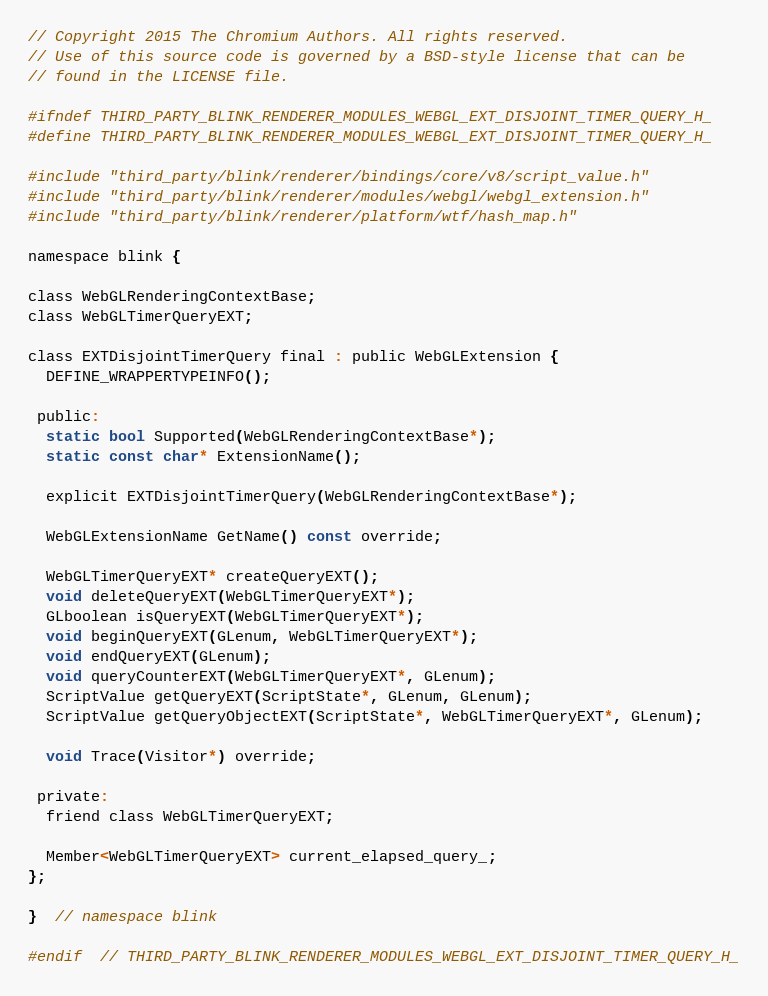<code> <loc_0><loc_0><loc_500><loc_500><_C_>// Copyright 2015 The Chromium Authors. All rights reserved.
// Use of this source code is governed by a BSD-style license that can be
// found in the LICENSE file.

#ifndef THIRD_PARTY_BLINK_RENDERER_MODULES_WEBGL_EXT_DISJOINT_TIMER_QUERY_H_
#define THIRD_PARTY_BLINK_RENDERER_MODULES_WEBGL_EXT_DISJOINT_TIMER_QUERY_H_

#include "third_party/blink/renderer/bindings/core/v8/script_value.h"
#include "third_party/blink/renderer/modules/webgl/webgl_extension.h"
#include "third_party/blink/renderer/platform/wtf/hash_map.h"

namespace blink {

class WebGLRenderingContextBase;
class WebGLTimerQueryEXT;

class EXTDisjointTimerQuery final : public WebGLExtension {
  DEFINE_WRAPPERTYPEINFO();

 public:
  static bool Supported(WebGLRenderingContextBase*);
  static const char* ExtensionName();

  explicit EXTDisjointTimerQuery(WebGLRenderingContextBase*);

  WebGLExtensionName GetName() const override;

  WebGLTimerQueryEXT* createQueryEXT();
  void deleteQueryEXT(WebGLTimerQueryEXT*);
  GLboolean isQueryEXT(WebGLTimerQueryEXT*);
  void beginQueryEXT(GLenum, WebGLTimerQueryEXT*);
  void endQueryEXT(GLenum);
  void queryCounterEXT(WebGLTimerQueryEXT*, GLenum);
  ScriptValue getQueryEXT(ScriptState*, GLenum, GLenum);
  ScriptValue getQueryObjectEXT(ScriptState*, WebGLTimerQueryEXT*, GLenum);

  void Trace(Visitor*) override;

 private:
  friend class WebGLTimerQueryEXT;

  Member<WebGLTimerQueryEXT> current_elapsed_query_;
};

}  // namespace blink

#endif  // THIRD_PARTY_BLINK_RENDERER_MODULES_WEBGL_EXT_DISJOINT_TIMER_QUERY_H_
</code> 